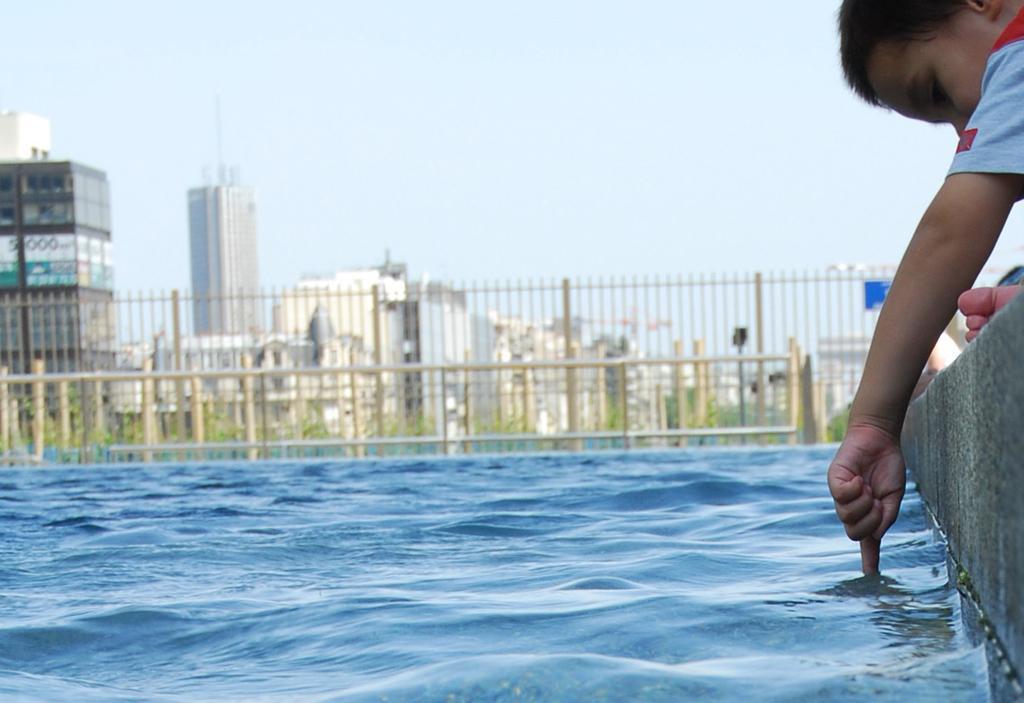In one or two sentences, can you explain what this image depicts? In this picture we can see water at the bottom, on the right side there is a kid, we can see fencing and plants in the middle, in the background there are some buildings, there is the sky at the top of the picture. 